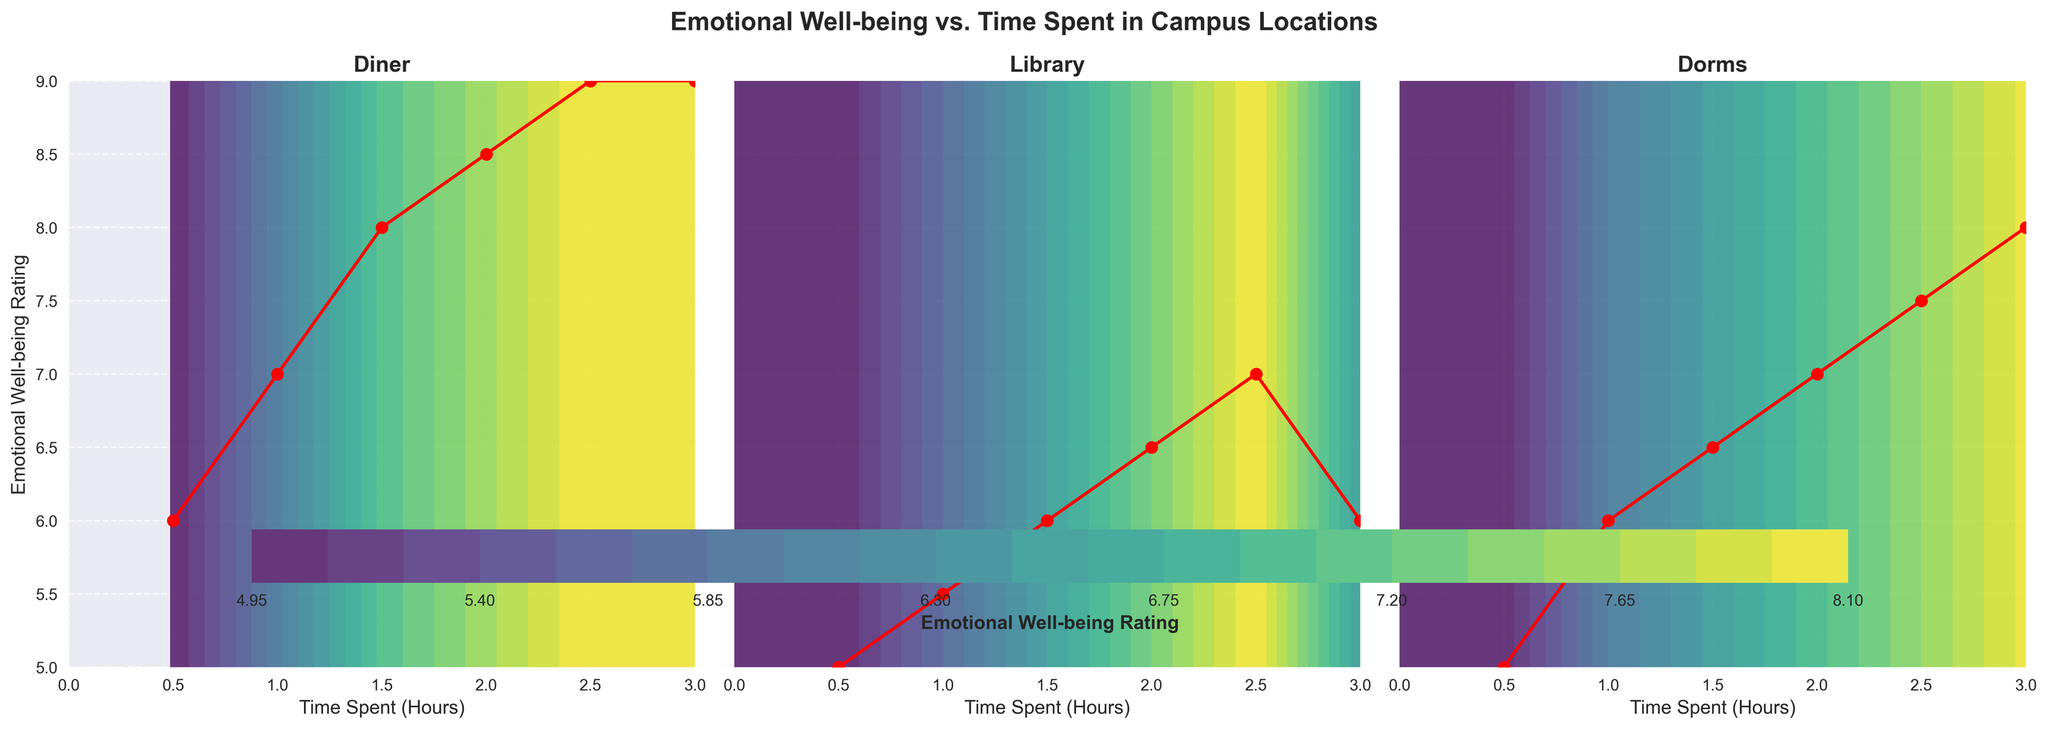What is the title of the figure? The title of the figure is clearly written at the top of the plot, stating "Emotional Well-being vs. Time Spent in Campus Locations".
Answer: Emotional Well-being vs. Time Spent in Campus Locations How many subplots are there in the figure? The figure comprises three subplots, one for each campus location (Diner, Library, Dorms), aligned horizontally.
Answer: Three What is the general trend of emotional well-being as time spent in the diner increases? The contour lines and plotted data points indicate an upward trend in emotional well-being ratings as the time spent in the diner increases from 0.5 hours to 3 hours.
Answer: Emotional well-being increases For which campus location does time spent show the highest variation in emotional well-being ratings? By comparing the range of emotional well-being ratings across the subplots, we can see that the "Diner" location shows the greatest change in ratings from 6 to 9.
Answer: Diner What is the emotional well-being rating at 2 hours spent in the dorms? The dotted lines and data points indicate a rating of 7 for 2 hours spent in the dorms.
Answer: 7 Which campus location has the steepest initial increase in emotional well-being ratings? By analyzing the slope of the plotted data points in the subplots, the "Diner" location shows the steepest initial increase in ratings, rising quickly from 6 to 8 within the first 1.5 hours.
Answer: Diner Is there a location where emotional well-being ratings decrease after an initial rise? The "Library" location shows an initial rise in ratings but then decreases from 7 to 6 as time spent goes from 2.5 hours to 3 hours.
Answer: Library At 1.5 hours, which location provides the highest emotional well-being rating? Comparing the ratings at 1.5 hours on each subplot, the diner has the highest rating of 8.
Answer: Diner How does the overall emotional well-being rating change in dorms as time spent increases? The contour plot and data points in the dorm subplot indicate a gradual but consistent increase in emotional well-being ratings from 5 to 8 as time spent increases from 0.5 hours to 3 hours.
Answer: Gradually increases Which location shows a more consistent emotional well-being range from 0.5 to 3 hours? The "Dorms" subplot displays a more consistent and linear increase in emotional well-being ratings, compared to the more variable trends in the "Diner" and "Library" subplots.
Answer: Dorms 